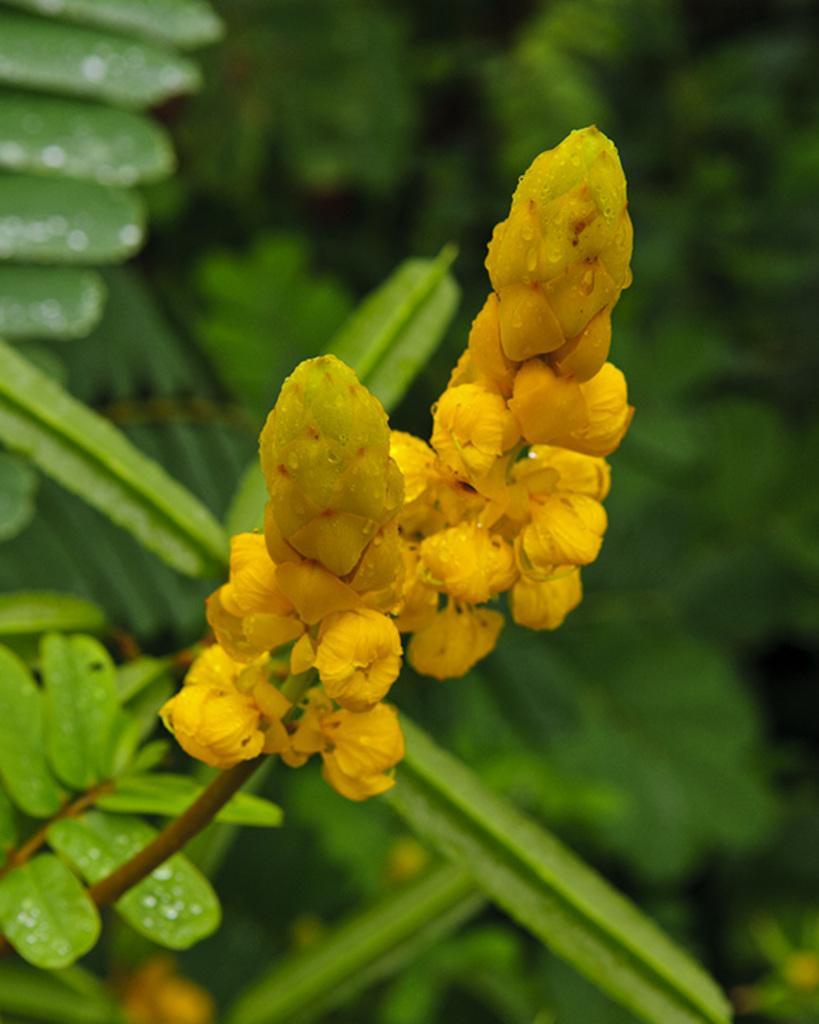Please provide a concise description of this image. In this image, we can see flower buds, stems and leaves. In the background, we can see the blur view and greenery. 